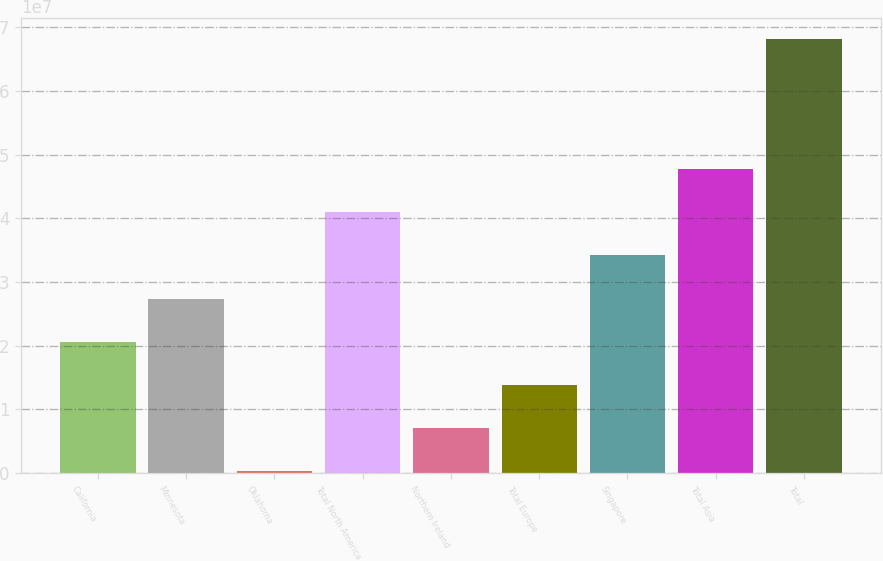Convert chart. <chart><loc_0><loc_0><loc_500><loc_500><bar_chart><fcel>California<fcel>Minnesota<fcel>Oklahoma<fcel>Total North America<fcel>Northern Ireland<fcel>Total Europe<fcel>Singapore<fcel>Total Asia<fcel>Total<nl><fcel>2.06218e+07<fcel>2.74063e+07<fcel>268220<fcel>4.09753e+07<fcel>7.05274e+06<fcel>1.38373e+07<fcel>3.41908e+07<fcel>4.77599e+07<fcel>6.81134e+07<nl></chart> 